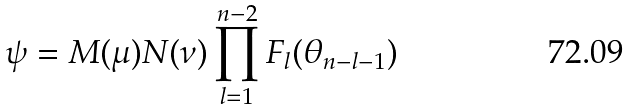Convert formula to latex. <formula><loc_0><loc_0><loc_500><loc_500>\psi = M ( \mu ) N ( \nu ) \prod _ { l = 1 } ^ { n - 2 } F _ { l } ( \theta _ { n - l - 1 } )</formula> 